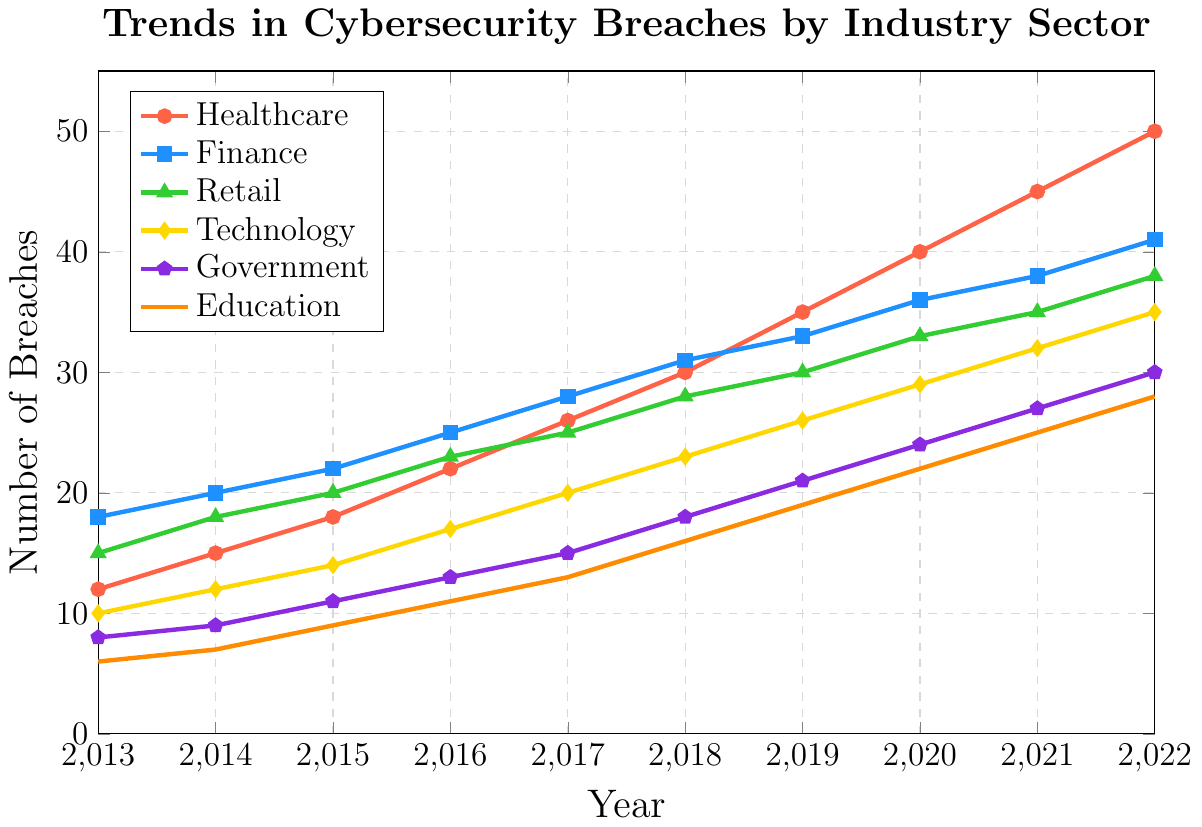What's the trend in cybersecurity breaches for the Healthcare sector from 2013 to 2022? The figure shows an increasing trend in cybersecurity breaches for the Healthcare sector, starting at 12 breaches in 2013 and growing steadily each year to reach 50 breaches by 2022.
Answer: Increasing Which industry had the most number of breaches in 2022? By examining the endpoints of the lines representing each industry, the Healthcare sector shows the highest endpoint at 50 breaches, making it the industry with the most number of breaches in 2022.
Answer: Healthcare How does the number of breaches in the Technology sector in 2016 compare to that in 2019? By comparing the coordinates for the Technology sector for the years 2016 and 2019, the number of breaches increased from 17 in 2016 to 26 in 2019.
Answer: Increased What was the rate of increase in breaches in the Government sector between 2013 and 2022? The breaches in the Government sector increased from 8 in 2013 to 30 in 2022. Calculating the rate: (30 - 8) / (2022 - 2013) = 22 / 9 ≈ 2.44 per year on average.
Answer: Approximately 2.44 per year Which sector showed the least increase in breaches over the decade? By visually comparing the increases for each industry, the Education sector, starting at 6 breaches in 2013 and ending with 28 breaches in 2022, shows the smallest numerical increase (from 6 to 28).
Answer: Education Compare the number of breaches in Finance and Retail sectors in 2020. By locating the year 2020 on the x-axis and comparing the y-values for Finance and Retail, Finance has 36 breaches and Retail has 33 breaches. Hence, Finance has more breaches compared to Retail in 2020.
Answer: Finance What is the average number of breaches for the Government sector over the decade? Sum of breaches for the Government sector: 8 + 9 + 11 + 13 + 15 + 18 + 21 + 24 + 27 + 30 = 176. The average is 176 / 10 = 17.6.
Answer: 17.6 Between 2017 and 2020, which sector had the highest increase in cybersecurity breaches? By calculating the differences for each sector between 2017 and 2020: Healthcare (40-26)=14, Finance (36-28)=8, Retail (33-25)=8, Technology (29-20)=9, Government (24-15)=9, Education (22-13)=9. Healthcare had the highest increase with 14 breaches.
Answer: Healthcare Which sector had a breach count closest to 35 in 2021? Referring to the values for each sector in 2021, the counts are as follows: Healthcare (45), Finance (38), Retail (35), Technology (32), Government (27), Education (25). Retail has exactly 35 breaches, closest to the given number.
Answer: Retail What is the overall trend observed in the number of breaches in the Education sector? The Education sector shows a steady increase in the number of breaches, growing from 6 breaches in 2013 to 28 breaches in 2022.
Answer: Increasing 